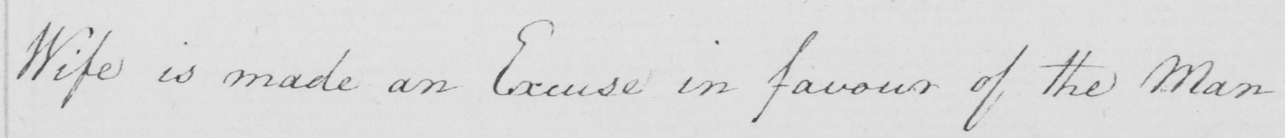Can you tell me what this handwritten text says? Wife is made an Excuse in favour of the Man . 